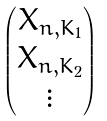<formula> <loc_0><loc_0><loc_500><loc_500>\begin{pmatrix} X _ { n , K _ { 1 } } \\ X _ { n , K _ { 2 } } \\ \vdots \end{pmatrix}</formula> 